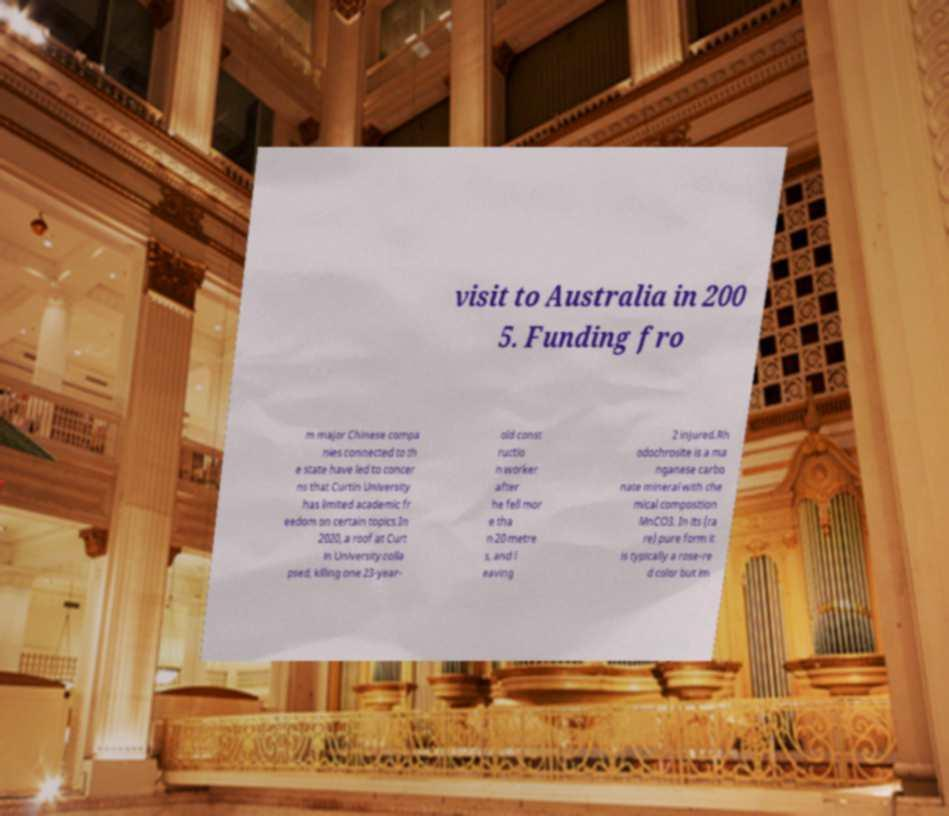Please read and relay the text visible in this image. What does it say? visit to Australia in 200 5. Funding fro m major Chinese compa nies connected to th e state have led to concer ns that Curtin University has limited academic fr eedom on certain topics.In 2020, a roof at Curt in University colla psed, killing one 23-year- old const ructio n worker after he fell mor e tha n 20 metre s, and l eaving 2 injured.Rh odochrosite is a ma nganese carbo nate mineral with che mical composition MnCO3. In its (ra re) pure form it is typically a rose-re d color but im 